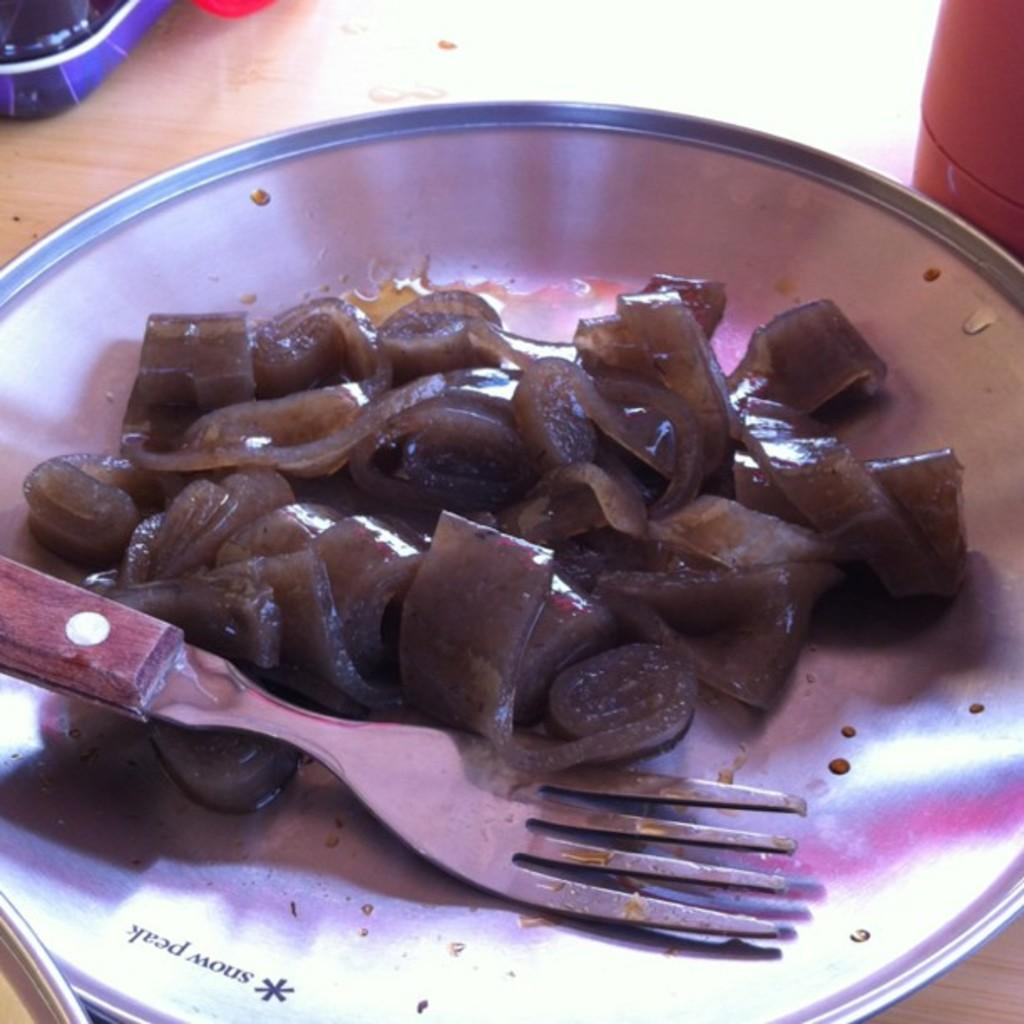What utensil can be seen in the image? There is a fork in the image. What is on the plate in the image? There are food items on a plate in the image. What is the plate resting on? The plate is on a wooden surface. What can be seen at the top of the image? There are objects visible at the top of the image. How does the person taste the food in the image? There is no person present in the image, so it is not possible to determine how they would taste the food. 